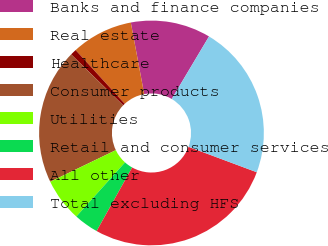<chart> <loc_0><loc_0><loc_500><loc_500><pie_chart><fcel>Banks and finance companies<fcel>Real estate<fcel>Healthcare<fcel>Consumer products<fcel>Utilities<fcel>Retail and consumer services<fcel>All other<fcel>Total excluding HFS<nl><fcel>11.5%<fcel>8.85%<fcel>0.88%<fcel>19.47%<fcel>6.19%<fcel>3.54%<fcel>27.43%<fcel>22.12%<nl></chart> 